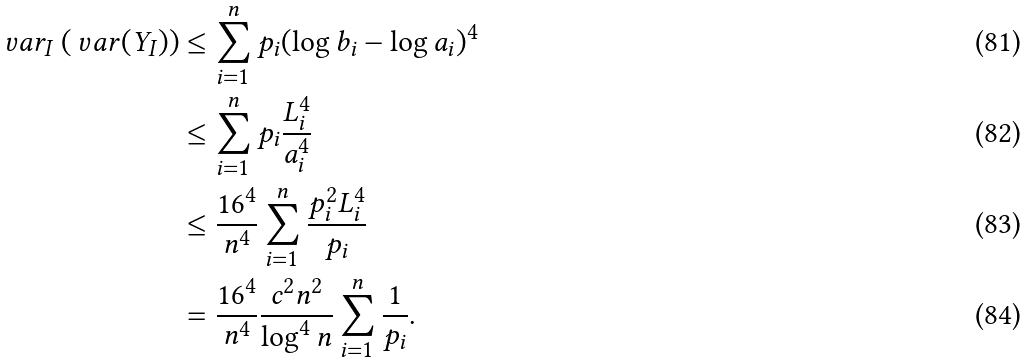<formula> <loc_0><loc_0><loc_500><loc_500>\ v a r _ { I } \left ( \ v a r ( Y _ { I } ) \right ) & \leq \sum _ { i = 1 } ^ { n } p _ { i } ( \log b _ { i } - \log a _ { i } ) ^ { 4 } \\ & \leq \sum _ { i = 1 } ^ { n } p _ { i } \frac { L _ { i } ^ { 4 } } { a _ { i } ^ { 4 } } \\ & \leq \frac { 1 6 ^ { 4 } } { n ^ { 4 } } \sum _ { i = 1 } ^ { n } \frac { p _ { i } ^ { 2 } L _ { i } ^ { 4 } } { p _ { i } } \\ & = \frac { 1 6 ^ { 4 } } { n ^ { 4 } } \frac { c ^ { 2 } n ^ { 2 } } { \log ^ { 4 } n } \sum _ { i = 1 } ^ { n } \frac { 1 } { p _ { i } } .</formula> 